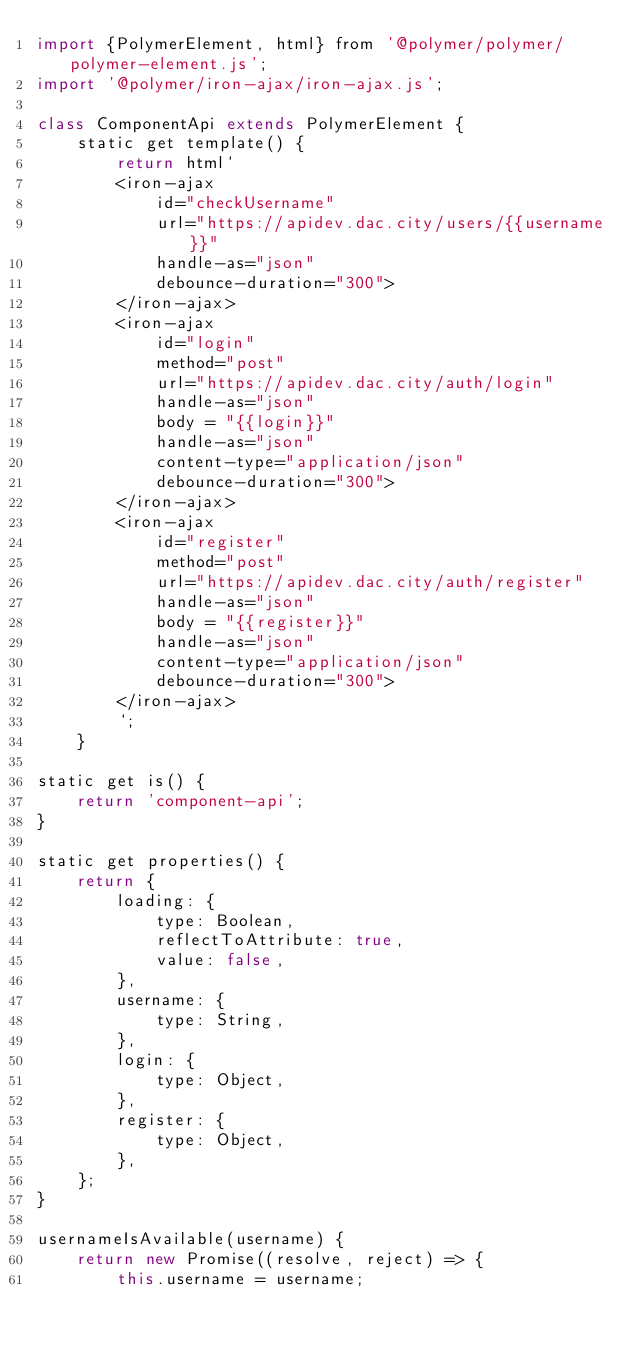Convert code to text. <code><loc_0><loc_0><loc_500><loc_500><_JavaScript_>import {PolymerElement, html} from '@polymer/polymer/polymer-element.js';
import '@polymer/iron-ajax/iron-ajax.js';

class ComponentApi extends PolymerElement {
    static get template() {
        return html`
        <iron-ajax
            id="checkUsername"
            url="https://apidev.dac.city/users/{{username}}"
            handle-as="json"
            debounce-duration="300">
        </iron-ajax>
        <iron-ajax
            id="login"
            method="post"
            url="https://apidev.dac.city/auth/login"
            handle-as="json"
            body = "{{login}}"
            handle-as="json"
            content-type="application/json"
            debounce-duration="300">
        </iron-ajax>
        <iron-ajax
            id="register"
            method="post"
            url="https://apidev.dac.city/auth/register"
            handle-as="json"
            body = "{{register}}"
            handle-as="json"
            content-type="application/json"
            debounce-duration="300">
        </iron-ajax>
        `;
    }

static get is() {
    return 'component-api';
}

static get properties() {
    return {
        loading: {
            type: Boolean,
            reflectToAttribute: true,
            value: false,
        },
        username: {
            type: String,
        },
        login: {
            type: Object,
        },
        register: {
            type: Object,
        },
    };
}

usernameIsAvailable(username) {
    return new Promise((resolve, reject) => {
        this.username = username;</code> 